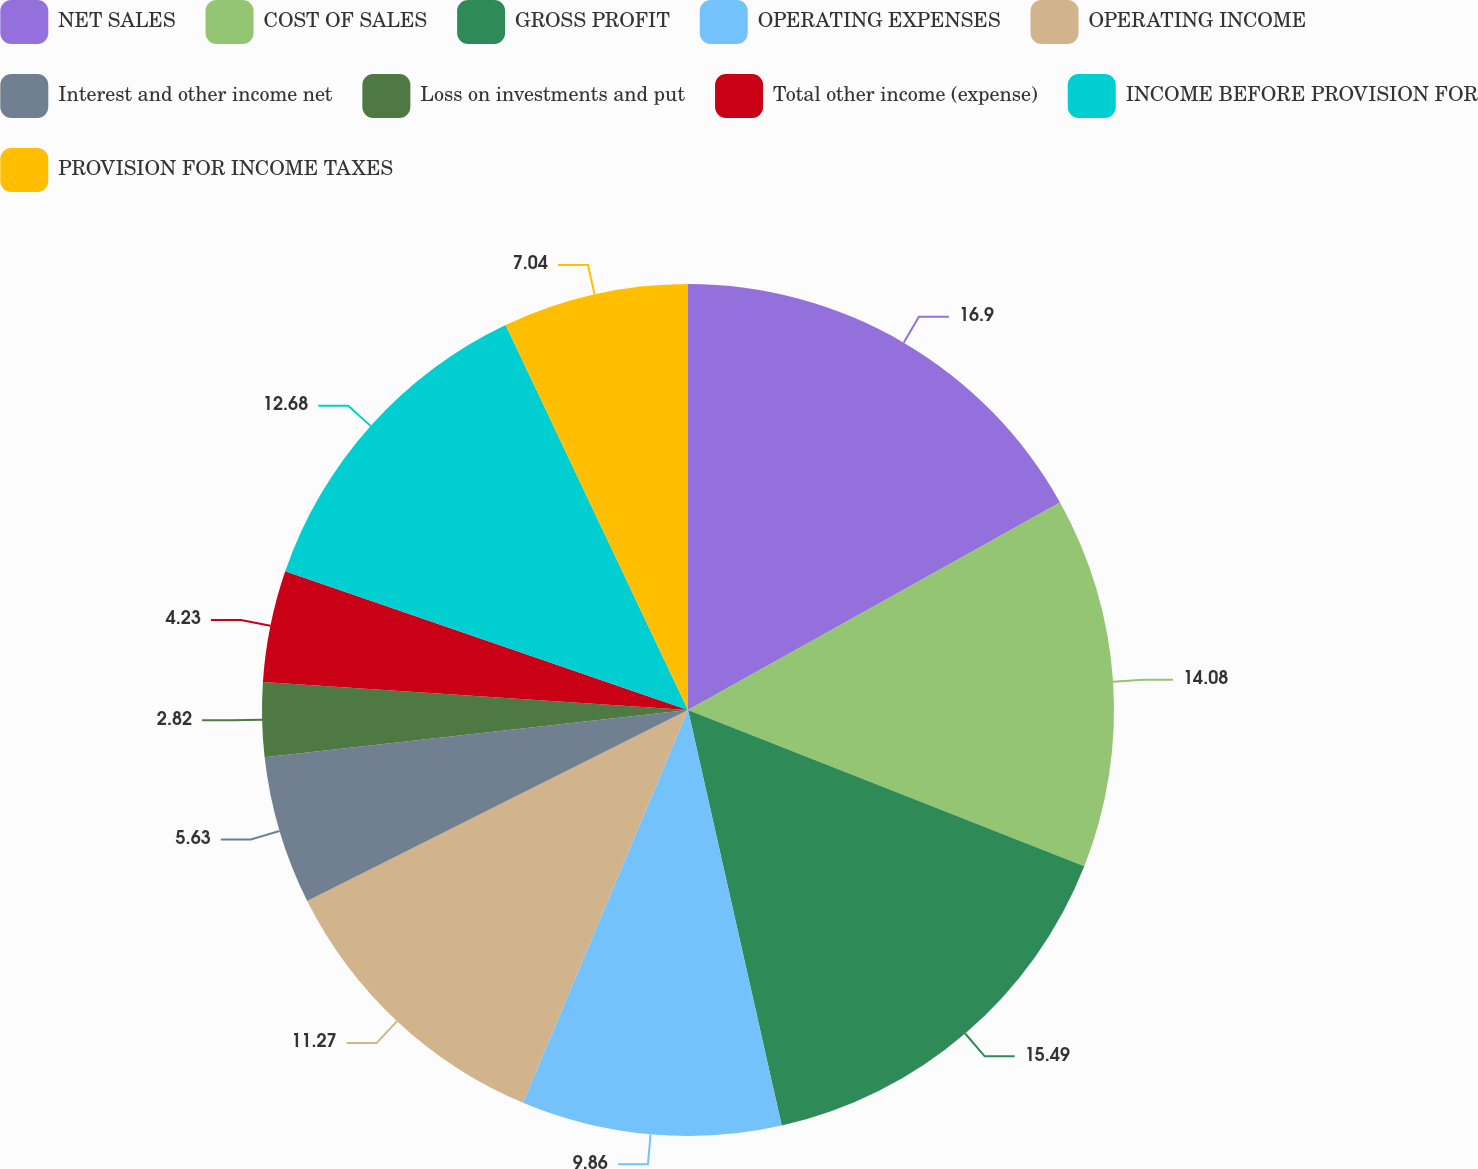Convert chart to OTSL. <chart><loc_0><loc_0><loc_500><loc_500><pie_chart><fcel>NET SALES<fcel>COST OF SALES<fcel>GROSS PROFIT<fcel>OPERATING EXPENSES<fcel>OPERATING INCOME<fcel>Interest and other income net<fcel>Loss on investments and put<fcel>Total other income (expense)<fcel>INCOME BEFORE PROVISION FOR<fcel>PROVISION FOR INCOME TAXES<nl><fcel>16.9%<fcel>14.08%<fcel>15.49%<fcel>9.86%<fcel>11.27%<fcel>5.63%<fcel>2.82%<fcel>4.23%<fcel>12.68%<fcel>7.04%<nl></chart> 